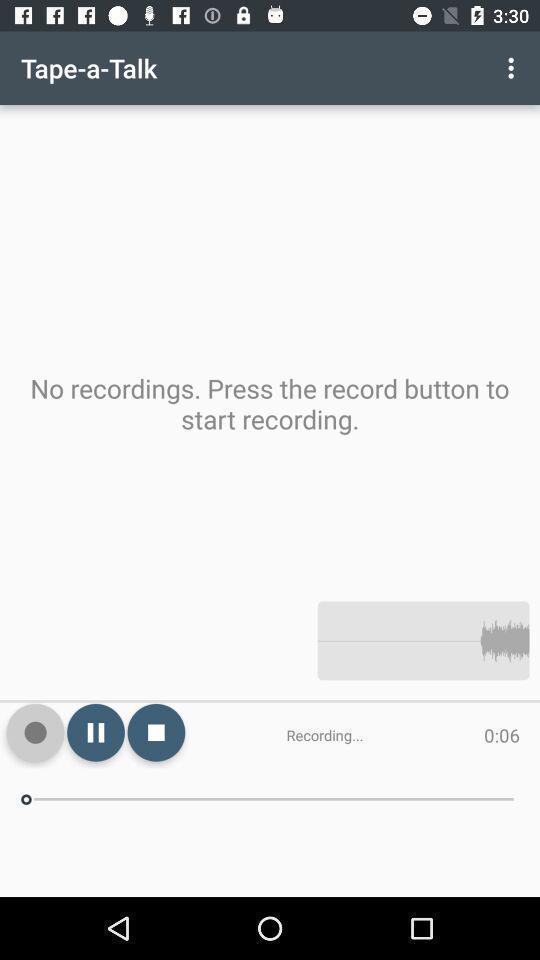Explain what's happening in this screen capture. Page for recording voice of an audio recording app. 